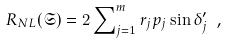Convert formula to latex. <formula><loc_0><loc_0><loc_500><loc_500>R _ { N L } ( { \mathfrak { S } } ) = 2 \sum \nolimits _ { j = 1 } ^ { m } r _ { j } p _ { j } \sin \delta ^ { \prime } _ { j } \ ,</formula> 